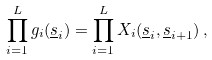<formula> <loc_0><loc_0><loc_500><loc_500>\prod _ { i = 1 } ^ { L } g _ { i } ( \underline { s } _ { i } ) = \prod _ { i = 1 } ^ { L } X _ { i } ( \underline { s } _ { i } , \underline { s } _ { i { + } 1 } ) \, ,</formula> 